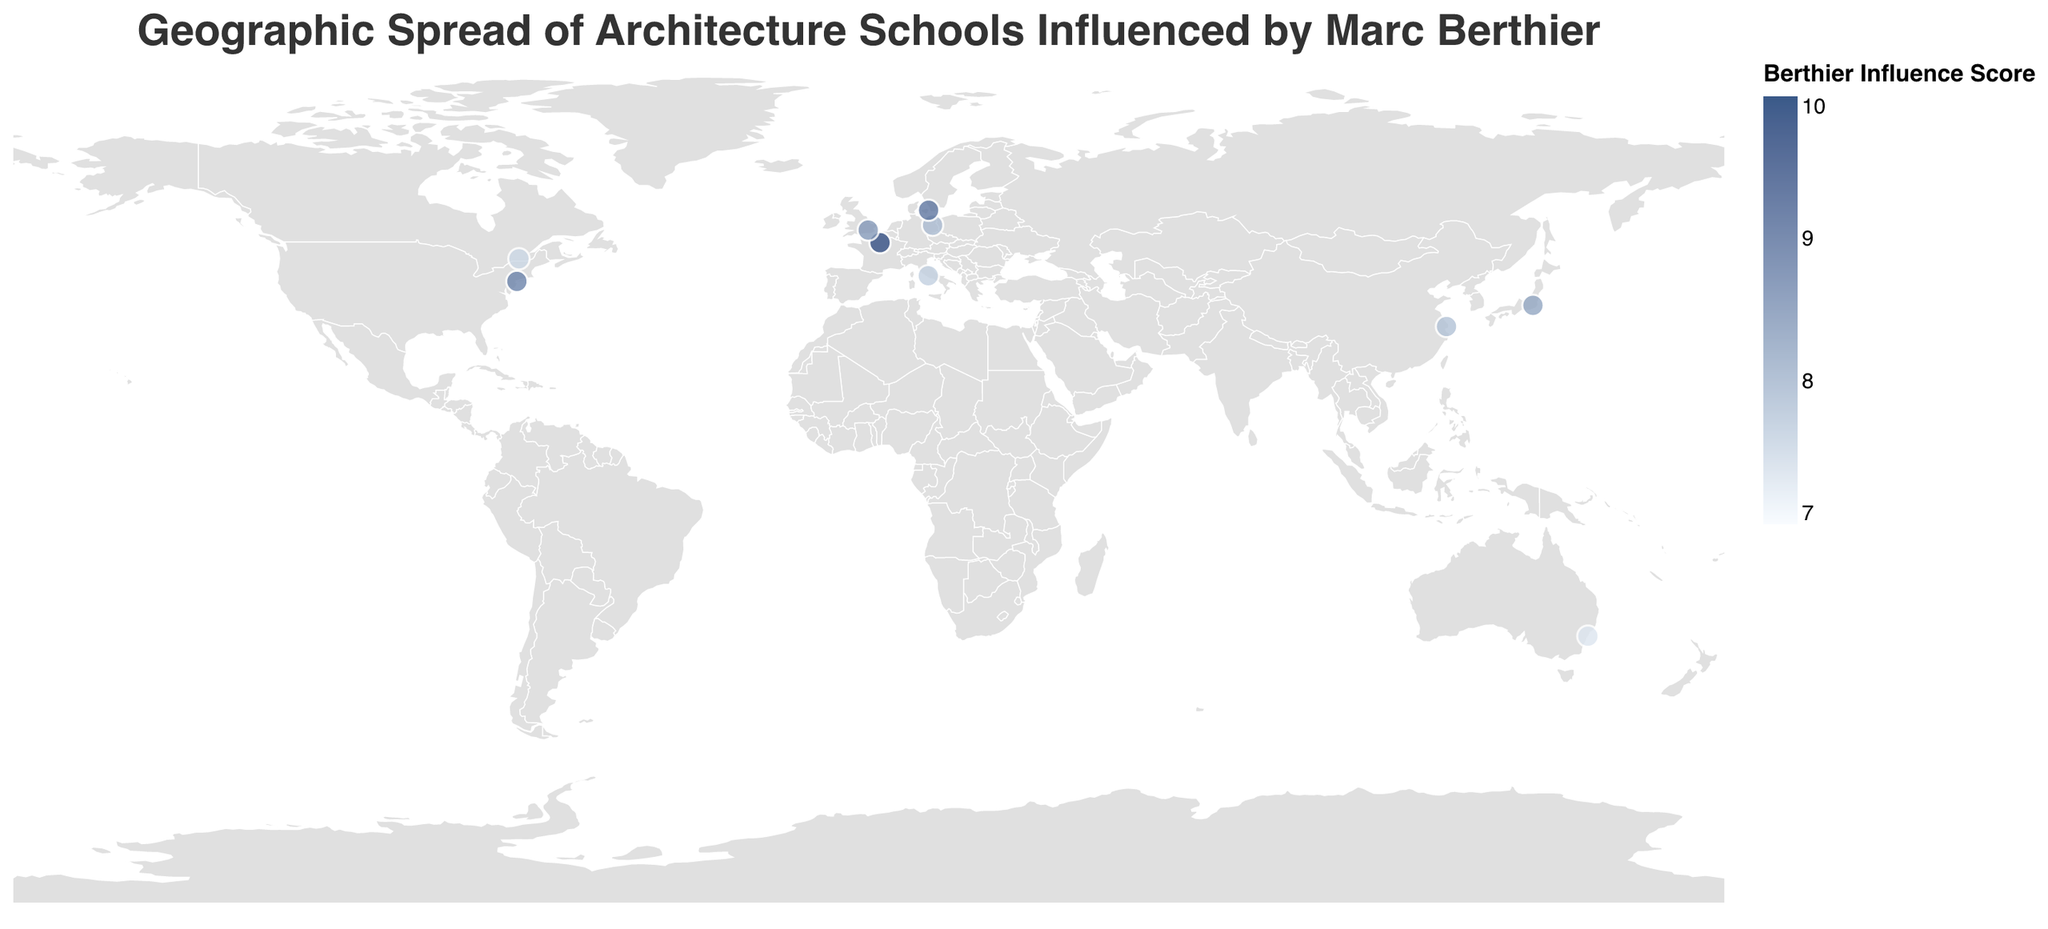Which school has the highest Berthier Influence Score? The color scale and tooltip can help us determine this. The darkest blue circle indicates the highest score in the chart. Hovering over the circles shows that École Spéciale d'Architecture has the highest score of 9.5.
Answer: École Spéciale d'Architecture Which country has more than one architecture school listed? By examining the data points on the map along with the tooltip, none of the countries have more than one school listed. Each country has only one specific school's data point.
Answer: None Which school in Asia has the highest Berthier Influence Score? The points for Asia would appear in the tooltip to be Tokyo Institute of Technology and Tongji University. Among these, Tokyo Institute of Technology has a score of 8.2 and Tongji University has a score of 7.8. Therefore, Tokyo Institute of Technology has the highest score.
Answer: Tokyo Institute of Technology How many architecture schools have a Berthier Influence Score greater than 8? By examining the color intensity of the circles and validating with the tooltip, we see that there are five schools with scores greater than 8: École Spéciale d'Architecture (9.5), Parsons School of Design (8.7), Royal Danish Academy of Fine Arts (8.9), Architectural Association School of Architecture (8.4), and Tokyo Institute of Technology (8.2).
Answer: 5 What is the average Berthier Influence Score of the schools located in Europe? First, identify the Europe-based schools: École Spéciale d'Architecture (9.5), Technische Universität Berlin (7.9), Sapienza University of Rome (7.6), and Royal Danish Academy of Fine Arts (8.9). Calculate the average: (9.5 + 7.9 + 7.6 + 8.9) / 4 = 8.475.
Answer: 8.475 Which school in North America has the lowest Berthier Influence Score? The North American schools listed are Parsons School of Design and McGill University. Through the tooltip, we can see that Parsons has a score of 8.7 and McGill has a score of 7.5. Therefore, McGill University has the lowest score among the two.
Answer: McGill University Are there any schools located in the Southern Hemisphere? If yes, name them. Observing the geographic locations, University of Technology Sydney is located in Australia, which is in the Southern Hemisphere.
Answer: University of Technology Sydney 